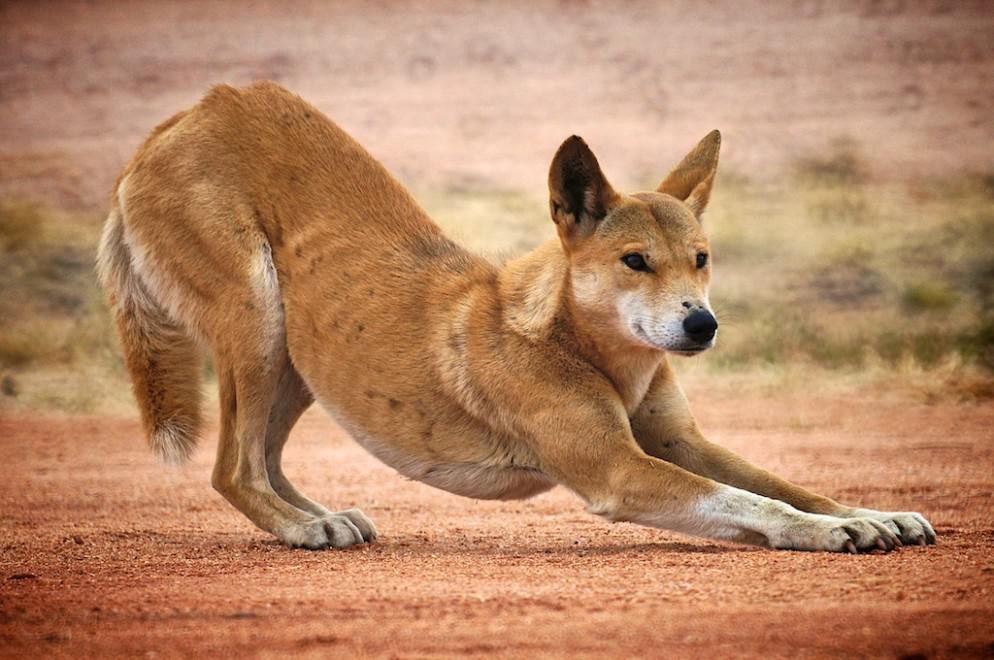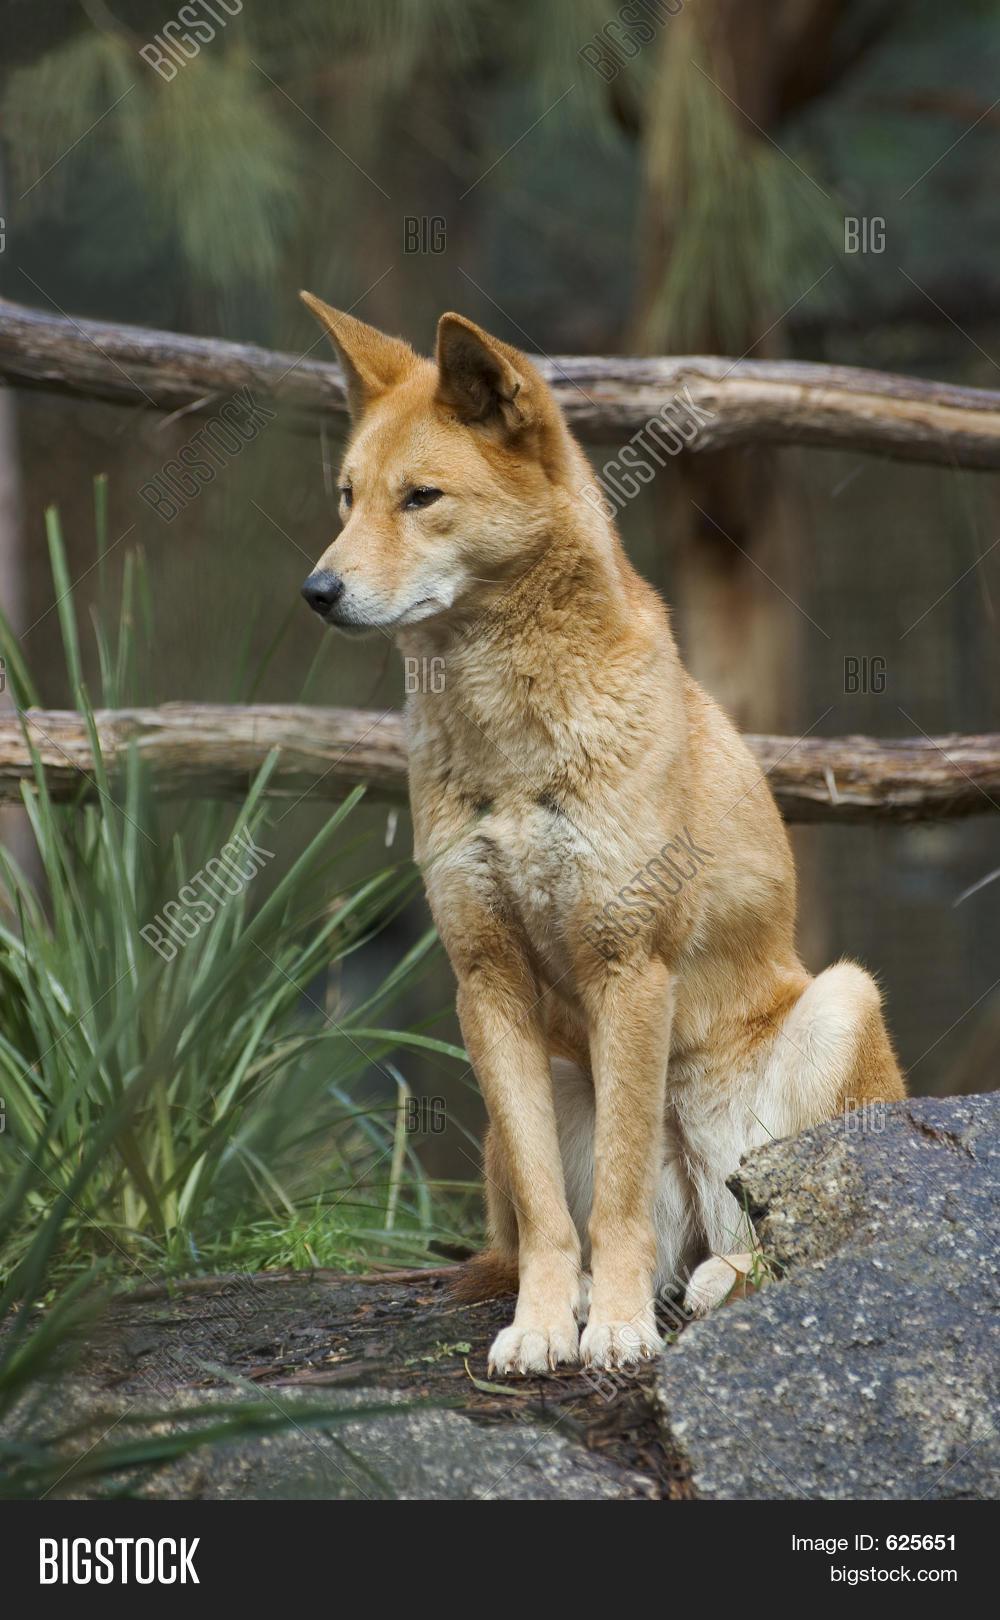The first image is the image on the left, the second image is the image on the right. Analyze the images presented: Is the assertion "There are exactly two canines, outdoors." valid? Answer yes or no. Yes. The first image is the image on the left, the second image is the image on the right. Assess this claim about the two images: "An image shows one dog sitting upright on a rock, with its head and gaze angled leftward.". Correct or not? Answer yes or no. Yes. 